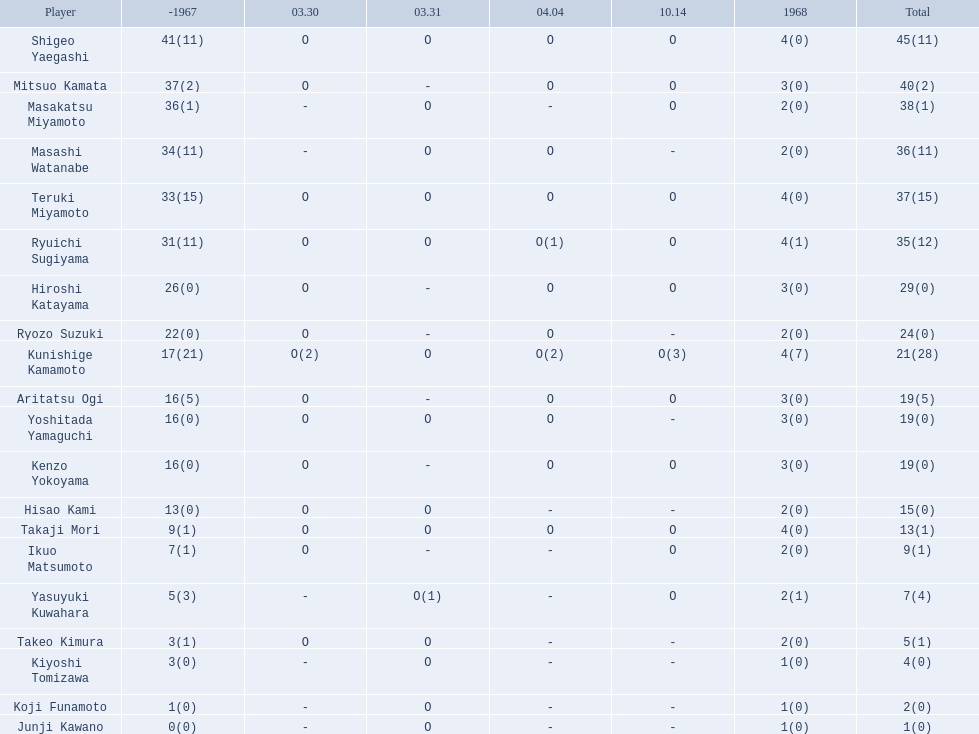Who are all of the players? Shigeo Yaegashi, Mitsuo Kamata, Masakatsu Miyamoto, Masashi Watanabe, Teruki Miyamoto, Ryuichi Sugiyama, Hiroshi Katayama, Ryozo Suzuki, Kunishige Kamamoto, Aritatsu Ogi, Yoshitada Yamaguchi, Kenzo Yokoyama, Hisao Kami, Takaji Mori, Ikuo Matsumoto, Yasuyuki Kuwahara, Takeo Kimura, Kiyoshi Tomizawa, Koji Funamoto, Junji Kawano. How many points did they receive? 45(11), 40(2), 38(1), 36(11), 37(15), 35(12), 29(0), 24(0), 21(28), 19(5), 19(0), 19(0), 15(0), 13(1), 9(1), 7(4), 5(1), 4(0), 2(0), 1(0). What about just takaji mori and junji kawano? 13(1), 1(0). Of the two, who had more points? Takaji Mori. 